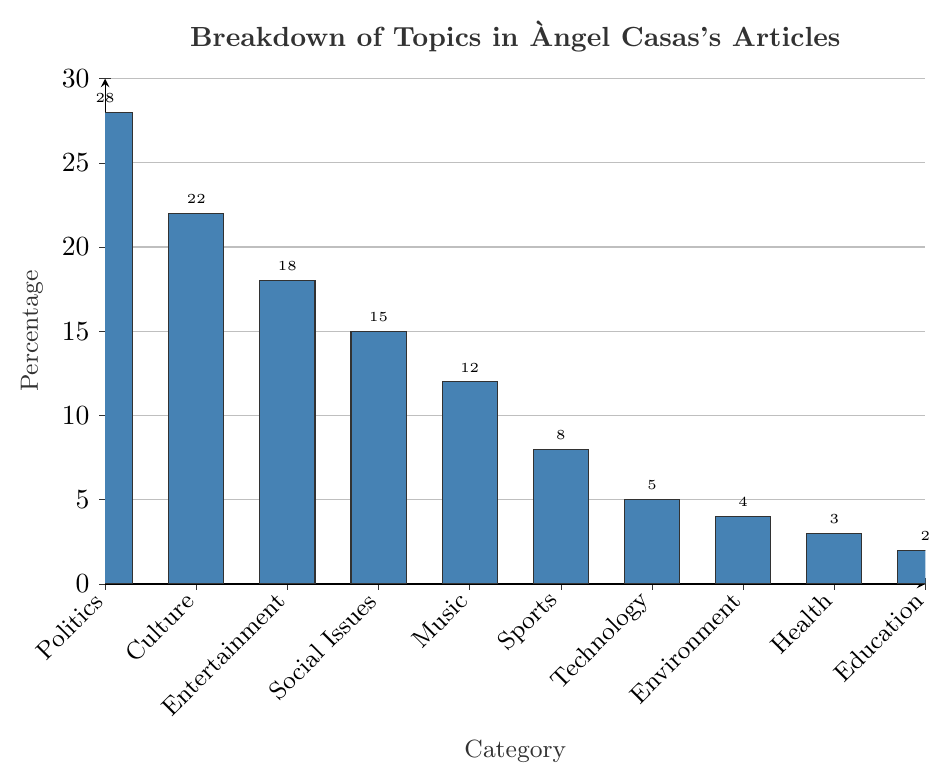What category covers the largest percentage of topics in Àngel Casas's articles? The tallest bar represents the category with the largest percentage. The tallest bar is labeled "Politics" with a height corresponding to 28%.
Answer: Politics Which category has the lowest percentage of coverage in the articles? The shortest bar shows the category with the lowest percentage. The shortest bar corresponds to "Education" at 2%.
Answer: Education What is the percentage difference between the topics "Politics" and "Education"? The percentage of "Politics" is 28% and "Education" is 2%. The difference is calculated by subtracting 2% from 28%.
Answer: 26% How much more coverage does "Culture" receive compared to "Technology"? "Culture" has 22% coverage, and "Technology" has 5%. Subtracting 5% from 22%, the difference is 17%.
Answer: 17% Which categories have a higher percentage of coverage than "Social Issues"? First, observe the percentage of "Social Issues," which is 15%. Categories with higher percentages are "Politics" (28%), "Culture" (22%), and "Entertainment" (18%).
Answer: Politics, Culture, Entertainment What is the total percentage of coverage for "Music," "Sports," and "Technology" combined? Add the percentages for "Music" (12%), "Sports" (8%), and "Technology" (5%). The sum is 12% + 8% + 5%, which equals 25%.
Answer: 25% Is the percentage of "Health" coverage greater than "Environment"? "Health" has 3% coverage and "Environment" has 4%. Since 3% is less than 4%, "Health" coverage is not greater than "Environment."
Answer: No How does the coverage of "Entertainment" compare to "Social Issues"? "Entertainment" has 18% coverage while "Social Issues" has 15%. Therefore, "Entertainment" receives 3% more coverage than "Social Issues."
Answer: 3% more What is the average percentage of coverage for "Politics," "Culture," and "Entertainment"? Add the percentages for these categories: 28% + 22% + 18%, which equals 68%. Dividing 68% by 3 categories provides the average: 68% / 3 = 22.67%.
Answer: 22.67% Which two categories have a combined coverage that equals the coverage of "Politics"? "Politics" has a coverage of 28%. Looking at pairs of categories, "Culture" (22%) and "Education" (2%) sum up to 24%, which is the closest but less than 28%, so there isn't a pair that equals "Politics."
Answer: None 